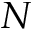<formula> <loc_0><loc_0><loc_500><loc_500>N</formula> 